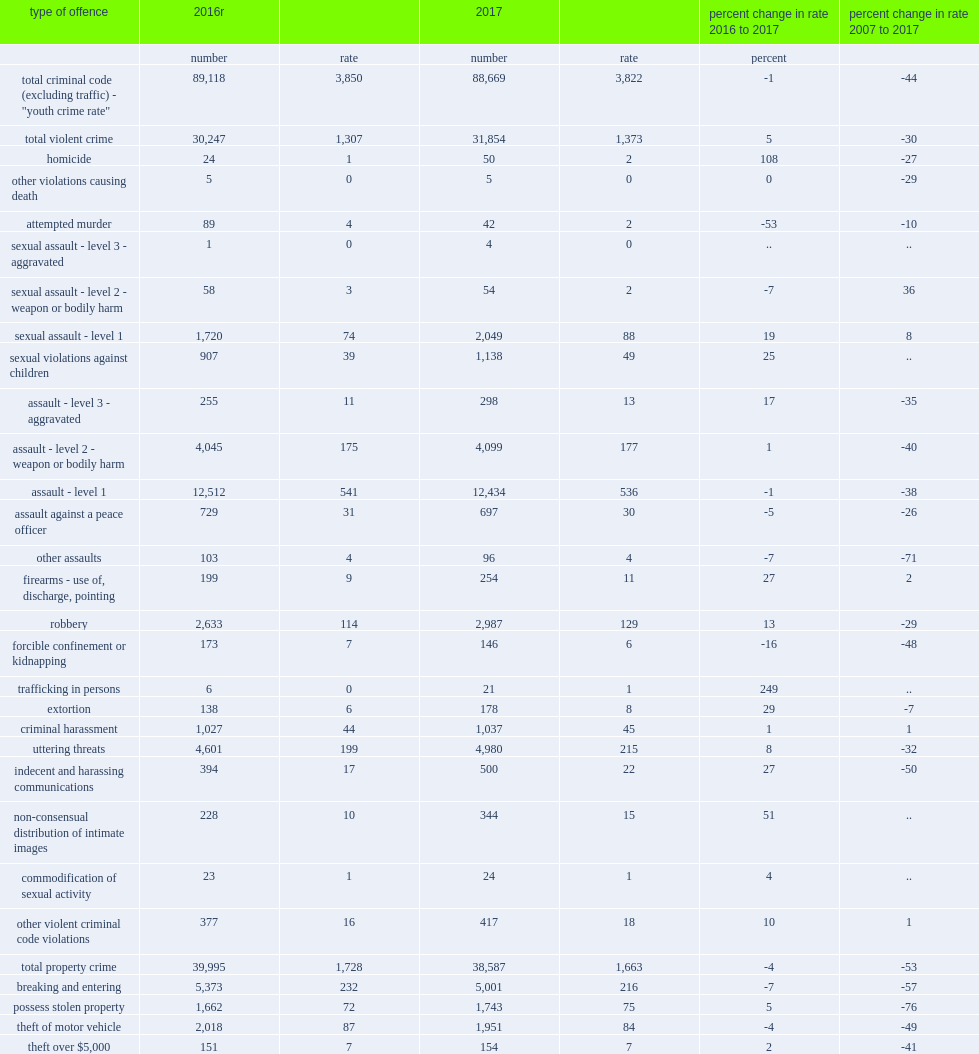List the most frequent criminal offences committed by youth in 2017. Theft of $5,000 or under. What was the rate of cannabis possession among youth in 2017? 342.0. What was the percent change in rate of sexual assault (level 1) and sexual violations against children from 2016 to 2017 respectively? 19.0 25.0. 